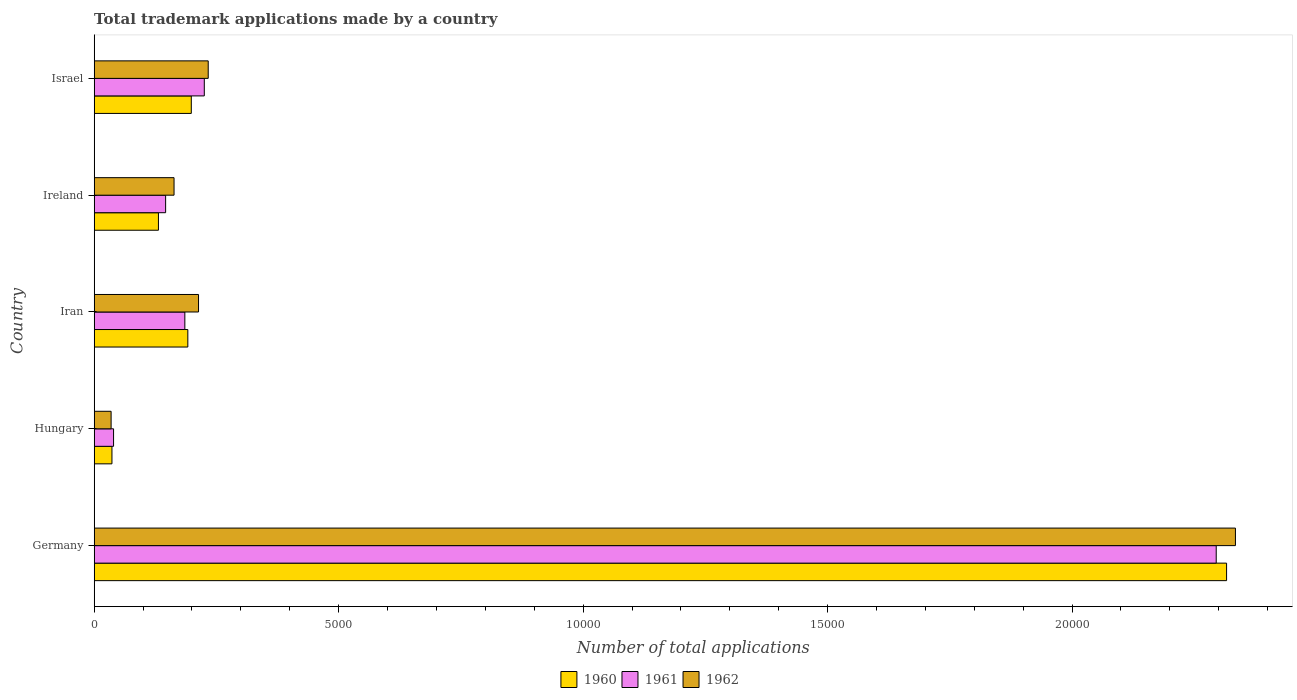How many different coloured bars are there?
Your answer should be compact. 3. How many bars are there on the 4th tick from the top?
Your answer should be very brief. 3. What is the label of the 4th group of bars from the top?
Offer a very short reply. Hungary. What is the number of applications made by in 1962 in Iran?
Offer a terse response. 2134. Across all countries, what is the maximum number of applications made by in 1960?
Your answer should be very brief. 2.32e+04. Across all countries, what is the minimum number of applications made by in 1961?
Provide a short and direct response. 396. In which country was the number of applications made by in 1960 maximum?
Make the answer very short. Germany. In which country was the number of applications made by in 1960 minimum?
Ensure brevity in your answer.  Hungary. What is the total number of applications made by in 1961 in the graph?
Offer a terse response. 2.89e+04. What is the difference between the number of applications made by in 1960 in Germany and that in Hungary?
Provide a short and direct response. 2.28e+04. What is the difference between the number of applications made by in 1960 in Israel and the number of applications made by in 1962 in Ireland?
Your response must be concise. 353. What is the average number of applications made by in 1962 per country?
Offer a terse response. 5957.4. What is the difference between the number of applications made by in 1962 and number of applications made by in 1960 in Iran?
Make the answer very short. 219. In how many countries, is the number of applications made by in 1961 greater than 19000 ?
Keep it short and to the point. 1. What is the ratio of the number of applications made by in 1962 in Germany to that in Hungary?
Offer a very short reply. 67.46. Is the number of applications made by in 1961 in Ireland less than that in Israel?
Your answer should be very brief. Yes. Is the difference between the number of applications made by in 1962 in Germany and Israel greater than the difference between the number of applications made by in 1960 in Germany and Israel?
Keep it short and to the point. No. What is the difference between the highest and the second highest number of applications made by in 1960?
Keep it short and to the point. 2.12e+04. What is the difference between the highest and the lowest number of applications made by in 1962?
Your answer should be very brief. 2.30e+04. In how many countries, is the number of applications made by in 1960 greater than the average number of applications made by in 1960 taken over all countries?
Offer a very short reply. 1. Is it the case that in every country, the sum of the number of applications made by in 1960 and number of applications made by in 1962 is greater than the number of applications made by in 1961?
Offer a very short reply. Yes. What is the difference between two consecutive major ticks on the X-axis?
Your response must be concise. 5000. Are the values on the major ticks of X-axis written in scientific E-notation?
Keep it short and to the point. No. Does the graph contain any zero values?
Make the answer very short. No. Does the graph contain grids?
Offer a very short reply. No. Where does the legend appear in the graph?
Your response must be concise. Bottom center. How many legend labels are there?
Your response must be concise. 3. How are the legend labels stacked?
Make the answer very short. Horizontal. What is the title of the graph?
Keep it short and to the point. Total trademark applications made by a country. What is the label or title of the X-axis?
Your response must be concise. Number of total applications. What is the Number of total applications in 1960 in Germany?
Your answer should be very brief. 2.32e+04. What is the Number of total applications in 1961 in Germany?
Your answer should be very brief. 2.29e+04. What is the Number of total applications of 1962 in Germany?
Provide a succinct answer. 2.33e+04. What is the Number of total applications in 1960 in Hungary?
Offer a very short reply. 363. What is the Number of total applications in 1961 in Hungary?
Provide a succinct answer. 396. What is the Number of total applications of 1962 in Hungary?
Give a very brief answer. 346. What is the Number of total applications in 1960 in Iran?
Your answer should be compact. 1915. What is the Number of total applications in 1961 in Iran?
Keep it short and to the point. 1854. What is the Number of total applications in 1962 in Iran?
Keep it short and to the point. 2134. What is the Number of total applications of 1960 in Ireland?
Offer a very short reply. 1314. What is the Number of total applications in 1961 in Ireland?
Provide a succinct answer. 1461. What is the Number of total applications of 1962 in Ireland?
Keep it short and to the point. 1633. What is the Number of total applications of 1960 in Israel?
Provide a short and direct response. 1986. What is the Number of total applications in 1961 in Israel?
Ensure brevity in your answer.  2252. What is the Number of total applications of 1962 in Israel?
Offer a terse response. 2332. Across all countries, what is the maximum Number of total applications of 1960?
Your answer should be compact. 2.32e+04. Across all countries, what is the maximum Number of total applications of 1961?
Your answer should be very brief. 2.29e+04. Across all countries, what is the maximum Number of total applications of 1962?
Make the answer very short. 2.33e+04. Across all countries, what is the minimum Number of total applications of 1960?
Provide a short and direct response. 363. Across all countries, what is the minimum Number of total applications in 1961?
Provide a short and direct response. 396. Across all countries, what is the minimum Number of total applications of 1962?
Provide a short and direct response. 346. What is the total Number of total applications of 1960 in the graph?
Give a very brief answer. 2.87e+04. What is the total Number of total applications of 1961 in the graph?
Provide a short and direct response. 2.89e+04. What is the total Number of total applications of 1962 in the graph?
Provide a short and direct response. 2.98e+04. What is the difference between the Number of total applications in 1960 in Germany and that in Hungary?
Provide a short and direct response. 2.28e+04. What is the difference between the Number of total applications of 1961 in Germany and that in Hungary?
Your response must be concise. 2.26e+04. What is the difference between the Number of total applications of 1962 in Germany and that in Hungary?
Offer a terse response. 2.30e+04. What is the difference between the Number of total applications in 1960 in Germany and that in Iran?
Your response must be concise. 2.12e+04. What is the difference between the Number of total applications of 1961 in Germany and that in Iran?
Keep it short and to the point. 2.11e+04. What is the difference between the Number of total applications of 1962 in Germany and that in Iran?
Your response must be concise. 2.12e+04. What is the difference between the Number of total applications in 1960 in Germany and that in Ireland?
Offer a terse response. 2.18e+04. What is the difference between the Number of total applications in 1961 in Germany and that in Ireland?
Offer a terse response. 2.15e+04. What is the difference between the Number of total applications in 1962 in Germany and that in Ireland?
Make the answer very short. 2.17e+04. What is the difference between the Number of total applications in 1960 in Germany and that in Israel?
Offer a very short reply. 2.12e+04. What is the difference between the Number of total applications of 1961 in Germany and that in Israel?
Your response must be concise. 2.07e+04. What is the difference between the Number of total applications of 1962 in Germany and that in Israel?
Your response must be concise. 2.10e+04. What is the difference between the Number of total applications in 1960 in Hungary and that in Iran?
Offer a very short reply. -1552. What is the difference between the Number of total applications in 1961 in Hungary and that in Iran?
Make the answer very short. -1458. What is the difference between the Number of total applications in 1962 in Hungary and that in Iran?
Your answer should be very brief. -1788. What is the difference between the Number of total applications of 1960 in Hungary and that in Ireland?
Your answer should be very brief. -951. What is the difference between the Number of total applications in 1961 in Hungary and that in Ireland?
Make the answer very short. -1065. What is the difference between the Number of total applications in 1962 in Hungary and that in Ireland?
Provide a short and direct response. -1287. What is the difference between the Number of total applications of 1960 in Hungary and that in Israel?
Offer a terse response. -1623. What is the difference between the Number of total applications in 1961 in Hungary and that in Israel?
Keep it short and to the point. -1856. What is the difference between the Number of total applications of 1962 in Hungary and that in Israel?
Ensure brevity in your answer.  -1986. What is the difference between the Number of total applications in 1960 in Iran and that in Ireland?
Your response must be concise. 601. What is the difference between the Number of total applications in 1961 in Iran and that in Ireland?
Make the answer very short. 393. What is the difference between the Number of total applications in 1962 in Iran and that in Ireland?
Your answer should be compact. 501. What is the difference between the Number of total applications of 1960 in Iran and that in Israel?
Offer a terse response. -71. What is the difference between the Number of total applications of 1961 in Iran and that in Israel?
Provide a short and direct response. -398. What is the difference between the Number of total applications of 1962 in Iran and that in Israel?
Make the answer very short. -198. What is the difference between the Number of total applications of 1960 in Ireland and that in Israel?
Keep it short and to the point. -672. What is the difference between the Number of total applications of 1961 in Ireland and that in Israel?
Provide a short and direct response. -791. What is the difference between the Number of total applications in 1962 in Ireland and that in Israel?
Ensure brevity in your answer.  -699. What is the difference between the Number of total applications in 1960 in Germany and the Number of total applications in 1961 in Hungary?
Your answer should be very brief. 2.28e+04. What is the difference between the Number of total applications in 1960 in Germany and the Number of total applications in 1962 in Hungary?
Your answer should be very brief. 2.28e+04. What is the difference between the Number of total applications in 1961 in Germany and the Number of total applications in 1962 in Hungary?
Keep it short and to the point. 2.26e+04. What is the difference between the Number of total applications of 1960 in Germany and the Number of total applications of 1961 in Iran?
Your answer should be compact. 2.13e+04. What is the difference between the Number of total applications in 1960 in Germany and the Number of total applications in 1962 in Iran?
Ensure brevity in your answer.  2.10e+04. What is the difference between the Number of total applications of 1961 in Germany and the Number of total applications of 1962 in Iran?
Offer a terse response. 2.08e+04. What is the difference between the Number of total applications in 1960 in Germany and the Number of total applications in 1961 in Ireland?
Your answer should be compact. 2.17e+04. What is the difference between the Number of total applications in 1960 in Germany and the Number of total applications in 1962 in Ireland?
Your answer should be very brief. 2.15e+04. What is the difference between the Number of total applications of 1961 in Germany and the Number of total applications of 1962 in Ireland?
Provide a short and direct response. 2.13e+04. What is the difference between the Number of total applications of 1960 in Germany and the Number of total applications of 1961 in Israel?
Your answer should be compact. 2.09e+04. What is the difference between the Number of total applications in 1960 in Germany and the Number of total applications in 1962 in Israel?
Offer a very short reply. 2.08e+04. What is the difference between the Number of total applications in 1961 in Germany and the Number of total applications in 1962 in Israel?
Give a very brief answer. 2.06e+04. What is the difference between the Number of total applications of 1960 in Hungary and the Number of total applications of 1961 in Iran?
Provide a short and direct response. -1491. What is the difference between the Number of total applications of 1960 in Hungary and the Number of total applications of 1962 in Iran?
Keep it short and to the point. -1771. What is the difference between the Number of total applications in 1961 in Hungary and the Number of total applications in 1962 in Iran?
Your answer should be very brief. -1738. What is the difference between the Number of total applications of 1960 in Hungary and the Number of total applications of 1961 in Ireland?
Keep it short and to the point. -1098. What is the difference between the Number of total applications of 1960 in Hungary and the Number of total applications of 1962 in Ireland?
Your response must be concise. -1270. What is the difference between the Number of total applications of 1961 in Hungary and the Number of total applications of 1962 in Ireland?
Give a very brief answer. -1237. What is the difference between the Number of total applications in 1960 in Hungary and the Number of total applications in 1961 in Israel?
Provide a short and direct response. -1889. What is the difference between the Number of total applications in 1960 in Hungary and the Number of total applications in 1962 in Israel?
Make the answer very short. -1969. What is the difference between the Number of total applications of 1961 in Hungary and the Number of total applications of 1962 in Israel?
Your response must be concise. -1936. What is the difference between the Number of total applications of 1960 in Iran and the Number of total applications of 1961 in Ireland?
Ensure brevity in your answer.  454. What is the difference between the Number of total applications in 1960 in Iran and the Number of total applications in 1962 in Ireland?
Provide a succinct answer. 282. What is the difference between the Number of total applications in 1961 in Iran and the Number of total applications in 1962 in Ireland?
Provide a succinct answer. 221. What is the difference between the Number of total applications in 1960 in Iran and the Number of total applications in 1961 in Israel?
Offer a terse response. -337. What is the difference between the Number of total applications in 1960 in Iran and the Number of total applications in 1962 in Israel?
Your answer should be compact. -417. What is the difference between the Number of total applications of 1961 in Iran and the Number of total applications of 1962 in Israel?
Provide a short and direct response. -478. What is the difference between the Number of total applications in 1960 in Ireland and the Number of total applications in 1961 in Israel?
Offer a very short reply. -938. What is the difference between the Number of total applications in 1960 in Ireland and the Number of total applications in 1962 in Israel?
Your answer should be very brief. -1018. What is the difference between the Number of total applications of 1961 in Ireland and the Number of total applications of 1962 in Israel?
Provide a succinct answer. -871. What is the average Number of total applications of 1960 per country?
Provide a short and direct response. 5747.8. What is the average Number of total applications of 1961 per country?
Provide a succinct answer. 5782.4. What is the average Number of total applications of 1962 per country?
Offer a terse response. 5957.4. What is the difference between the Number of total applications of 1960 and Number of total applications of 1961 in Germany?
Provide a short and direct response. 212. What is the difference between the Number of total applications in 1960 and Number of total applications in 1962 in Germany?
Your answer should be compact. -181. What is the difference between the Number of total applications in 1961 and Number of total applications in 1962 in Germany?
Provide a succinct answer. -393. What is the difference between the Number of total applications in 1960 and Number of total applications in 1961 in Hungary?
Offer a very short reply. -33. What is the difference between the Number of total applications in 1960 and Number of total applications in 1962 in Hungary?
Keep it short and to the point. 17. What is the difference between the Number of total applications in 1960 and Number of total applications in 1961 in Iran?
Provide a short and direct response. 61. What is the difference between the Number of total applications in 1960 and Number of total applications in 1962 in Iran?
Provide a short and direct response. -219. What is the difference between the Number of total applications in 1961 and Number of total applications in 1962 in Iran?
Provide a succinct answer. -280. What is the difference between the Number of total applications in 1960 and Number of total applications in 1961 in Ireland?
Give a very brief answer. -147. What is the difference between the Number of total applications in 1960 and Number of total applications in 1962 in Ireland?
Offer a terse response. -319. What is the difference between the Number of total applications in 1961 and Number of total applications in 1962 in Ireland?
Give a very brief answer. -172. What is the difference between the Number of total applications of 1960 and Number of total applications of 1961 in Israel?
Give a very brief answer. -266. What is the difference between the Number of total applications in 1960 and Number of total applications in 1962 in Israel?
Ensure brevity in your answer.  -346. What is the difference between the Number of total applications in 1961 and Number of total applications in 1962 in Israel?
Keep it short and to the point. -80. What is the ratio of the Number of total applications of 1960 in Germany to that in Hungary?
Your response must be concise. 63.8. What is the ratio of the Number of total applications in 1961 in Germany to that in Hungary?
Give a very brief answer. 57.95. What is the ratio of the Number of total applications of 1962 in Germany to that in Hungary?
Your answer should be very brief. 67.46. What is the ratio of the Number of total applications in 1960 in Germany to that in Iran?
Make the answer very short. 12.09. What is the ratio of the Number of total applications in 1961 in Germany to that in Iran?
Give a very brief answer. 12.38. What is the ratio of the Number of total applications of 1962 in Germany to that in Iran?
Provide a succinct answer. 10.94. What is the ratio of the Number of total applications in 1960 in Germany to that in Ireland?
Make the answer very short. 17.63. What is the ratio of the Number of total applications in 1961 in Germany to that in Ireland?
Make the answer very short. 15.71. What is the ratio of the Number of total applications in 1962 in Germany to that in Ireland?
Provide a short and direct response. 14.29. What is the ratio of the Number of total applications of 1960 in Germany to that in Israel?
Keep it short and to the point. 11.66. What is the ratio of the Number of total applications of 1961 in Germany to that in Israel?
Offer a very short reply. 10.19. What is the ratio of the Number of total applications in 1962 in Germany to that in Israel?
Offer a terse response. 10.01. What is the ratio of the Number of total applications in 1960 in Hungary to that in Iran?
Your response must be concise. 0.19. What is the ratio of the Number of total applications in 1961 in Hungary to that in Iran?
Provide a succinct answer. 0.21. What is the ratio of the Number of total applications of 1962 in Hungary to that in Iran?
Provide a short and direct response. 0.16. What is the ratio of the Number of total applications of 1960 in Hungary to that in Ireland?
Your response must be concise. 0.28. What is the ratio of the Number of total applications of 1961 in Hungary to that in Ireland?
Offer a terse response. 0.27. What is the ratio of the Number of total applications of 1962 in Hungary to that in Ireland?
Offer a terse response. 0.21. What is the ratio of the Number of total applications of 1960 in Hungary to that in Israel?
Keep it short and to the point. 0.18. What is the ratio of the Number of total applications in 1961 in Hungary to that in Israel?
Keep it short and to the point. 0.18. What is the ratio of the Number of total applications in 1962 in Hungary to that in Israel?
Provide a short and direct response. 0.15. What is the ratio of the Number of total applications of 1960 in Iran to that in Ireland?
Your response must be concise. 1.46. What is the ratio of the Number of total applications of 1961 in Iran to that in Ireland?
Provide a succinct answer. 1.27. What is the ratio of the Number of total applications in 1962 in Iran to that in Ireland?
Provide a short and direct response. 1.31. What is the ratio of the Number of total applications in 1960 in Iran to that in Israel?
Make the answer very short. 0.96. What is the ratio of the Number of total applications in 1961 in Iran to that in Israel?
Your response must be concise. 0.82. What is the ratio of the Number of total applications in 1962 in Iran to that in Israel?
Make the answer very short. 0.92. What is the ratio of the Number of total applications in 1960 in Ireland to that in Israel?
Provide a succinct answer. 0.66. What is the ratio of the Number of total applications of 1961 in Ireland to that in Israel?
Your response must be concise. 0.65. What is the ratio of the Number of total applications of 1962 in Ireland to that in Israel?
Make the answer very short. 0.7. What is the difference between the highest and the second highest Number of total applications in 1960?
Your answer should be very brief. 2.12e+04. What is the difference between the highest and the second highest Number of total applications of 1961?
Ensure brevity in your answer.  2.07e+04. What is the difference between the highest and the second highest Number of total applications in 1962?
Offer a very short reply. 2.10e+04. What is the difference between the highest and the lowest Number of total applications in 1960?
Your answer should be compact. 2.28e+04. What is the difference between the highest and the lowest Number of total applications of 1961?
Keep it short and to the point. 2.26e+04. What is the difference between the highest and the lowest Number of total applications of 1962?
Provide a succinct answer. 2.30e+04. 